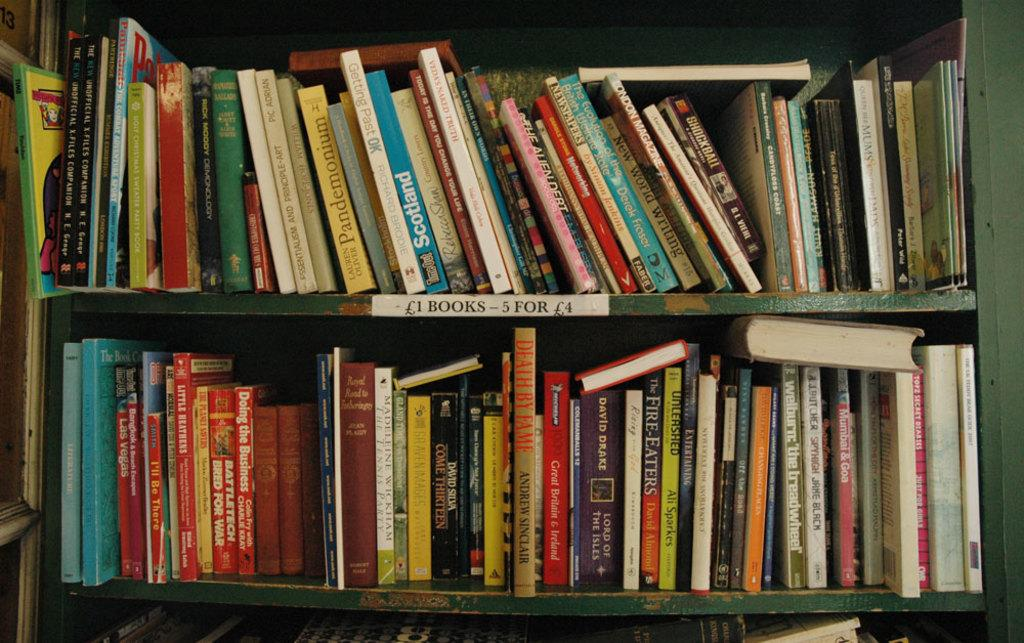<image>
Describe the image concisely. A book by Rick Moody on the top self of the book case. 